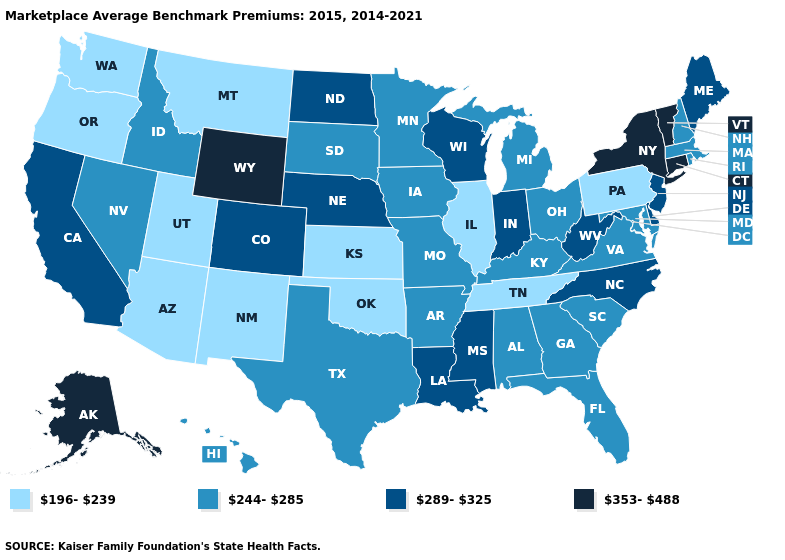Name the states that have a value in the range 353-488?
Short answer required. Alaska, Connecticut, New York, Vermont, Wyoming. Which states have the highest value in the USA?
Quick response, please. Alaska, Connecticut, New York, Vermont, Wyoming. Name the states that have a value in the range 289-325?
Give a very brief answer. California, Colorado, Delaware, Indiana, Louisiana, Maine, Mississippi, Nebraska, New Jersey, North Carolina, North Dakota, West Virginia, Wisconsin. Among the states that border Georgia , which have the lowest value?
Quick response, please. Tennessee. How many symbols are there in the legend?
Be succinct. 4. What is the value of Maryland?
Answer briefly. 244-285. Among the states that border South Carolina , does North Carolina have the highest value?
Give a very brief answer. Yes. What is the value of Wyoming?
Answer briefly. 353-488. Does Indiana have the same value as Maine?
Keep it brief. Yes. Does West Virginia have the same value as Oregon?
Keep it brief. No. Is the legend a continuous bar?
Keep it brief. No. Name the states that have a value in the range 289-325?
Concise answer only. California, Colorado, Delaware, Indiana, Louisiana, Maine, Mississippi, Nebraska, New Jersey, North Carolina, North Dakota, West Virginia, Wisconsin. What is the value of Oregon?
Write a very short answer. 196-239. Name the states that have a value in the range 244-285?
Short answer required. Alabama, Arkansas, Florida, Georgia, Hawaii, Idaho, Iowa, Kentucky, Maryland, Massachusetts, Michigan, Minnesota, Missouri, Nevada, New Hampshire, Ohio, Rhode Island, South Carolina, South Dakota, Texas, Virginia. What is the value of Utah?
Short answer required. 196-239. 